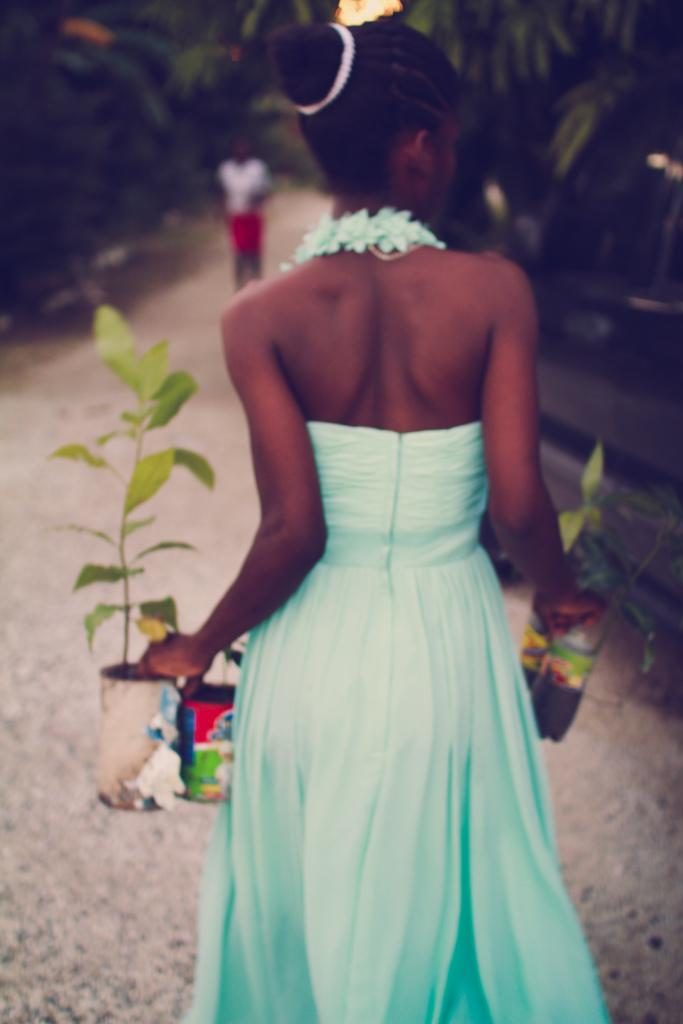Who is the main subject in the image? There is a girl in the image. What is the girl holding in her hands? The girl is holding plants in her hands. What is the girl doing in the image? The girl is walking on a road. Can you describe the person in the background of the image? The person in the background is blurred. What type of pie is the girl eating while walking on the road? There is no pie present in the image; the girl is holding plants in her hands. 